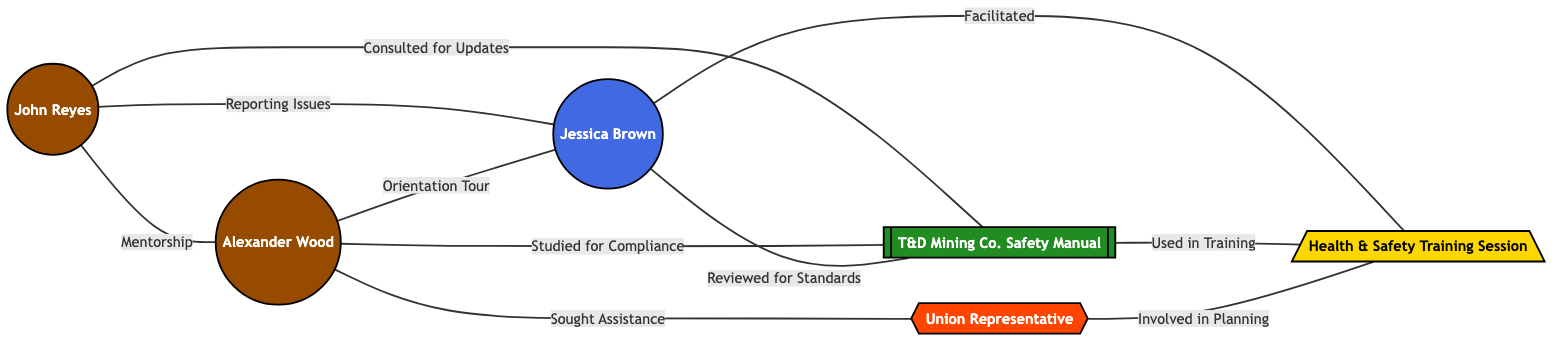What is the role of node 1? Node 1 is labeled "John Reyes" and is identified as an "Experienced Miner."
Answer: Experienced Miner How many edges are connected to node 3? Node 3 connects to four other nodes: node 1 (Reporting Issues), node 2 (Orientation Tour), node 4 (Reviewed for Standards), and node 6 (Facilitated). Therefore, it has four edges.
Answer: 4 Who provides mentorship to new miners? Node 1, which is "John Reyes," provides mentorship to node 2, which is "Alexander Wood." The label on the edge confirms this relationship.
Answer: John Reyes What is the relationship labeled between nodes 2 and 5? The edge connecting nodes 2 and 5 is labeled "Sought Assistance," indicating that Alexander Wood sought assistance from the Union Representative.
Answer: Sought Assistance Which node serves as reference material? Node 4 is labeled "T&D Mining Co. Safety Manual," which categorizes it as reference material for the other nodes.
Answer: T&D Mining Co. Safety Manual What is the out-degree of node 2? Node 2 has three outgoing connections: to node 3 (Orientation Tour), node 4 (Studied for Compliance), and node 5 (Sought Assistance), indicating an out-degree of three.
Answer: 3 Which node is involved in planning training sessions? The Union Representative, found at node 5, is involved in planning the Health & Safety Training Session, which is represented by node 6.
Answer: Union Representative How many total nodes are represented in the graph? The graph contains six nodes: John Reyes, Alexander Wood, Jessica Brown, T&D Mining Co. Safety Manual, Union Representative, and Health & Safety Training Session.
Answer: 6 Which node is responsible for facilitating a training session? Node 3, labeled as "Jessica Brown," is responsible for facilitating the Health & Safety Training Session, represented by node 6.
Answer: Jessica Brown 